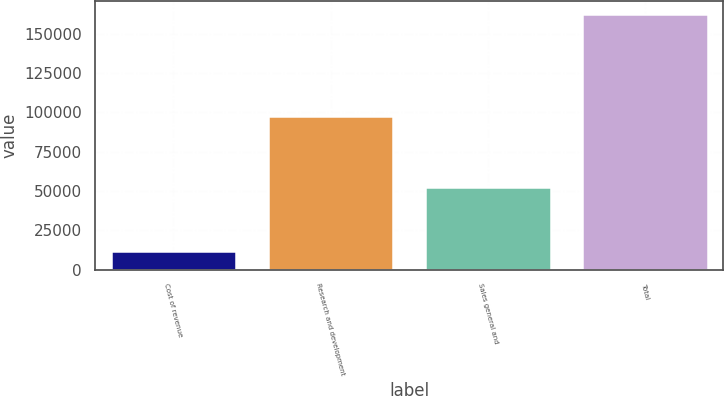<chart> <loc_0><loc_0><loc_500><loc_500><bar_chart><fcel>Cost of revenue<fcel>Research and development<fcel>Sales general and<fcel>Total<nl><fcel>11939<fcel>98007<fcel>52760<fcel>162706<nl></chart> 